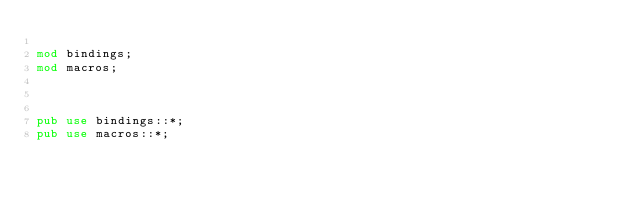<code> <loc_0><loc_0><loc_500><loc_500><_Rust_>
mod bindings;
mod macros;



pub use bindings::*;
pub use macros::*;</code> 